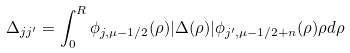Convert formula to latex. <formula><loc_0><loc_0><loc_500><loc_500>\Delta _ { j j ^ { \prime } } = \int _ { 0 } ^ { R } \phi _ { j , \mu - 1 / 2 } ( \rho ) | \Delta ( \rho ) | \phi _ { j ^ { \prime } , \mu - 1 / 2 + n } ( \rho ) \rho d \rho</formula> 